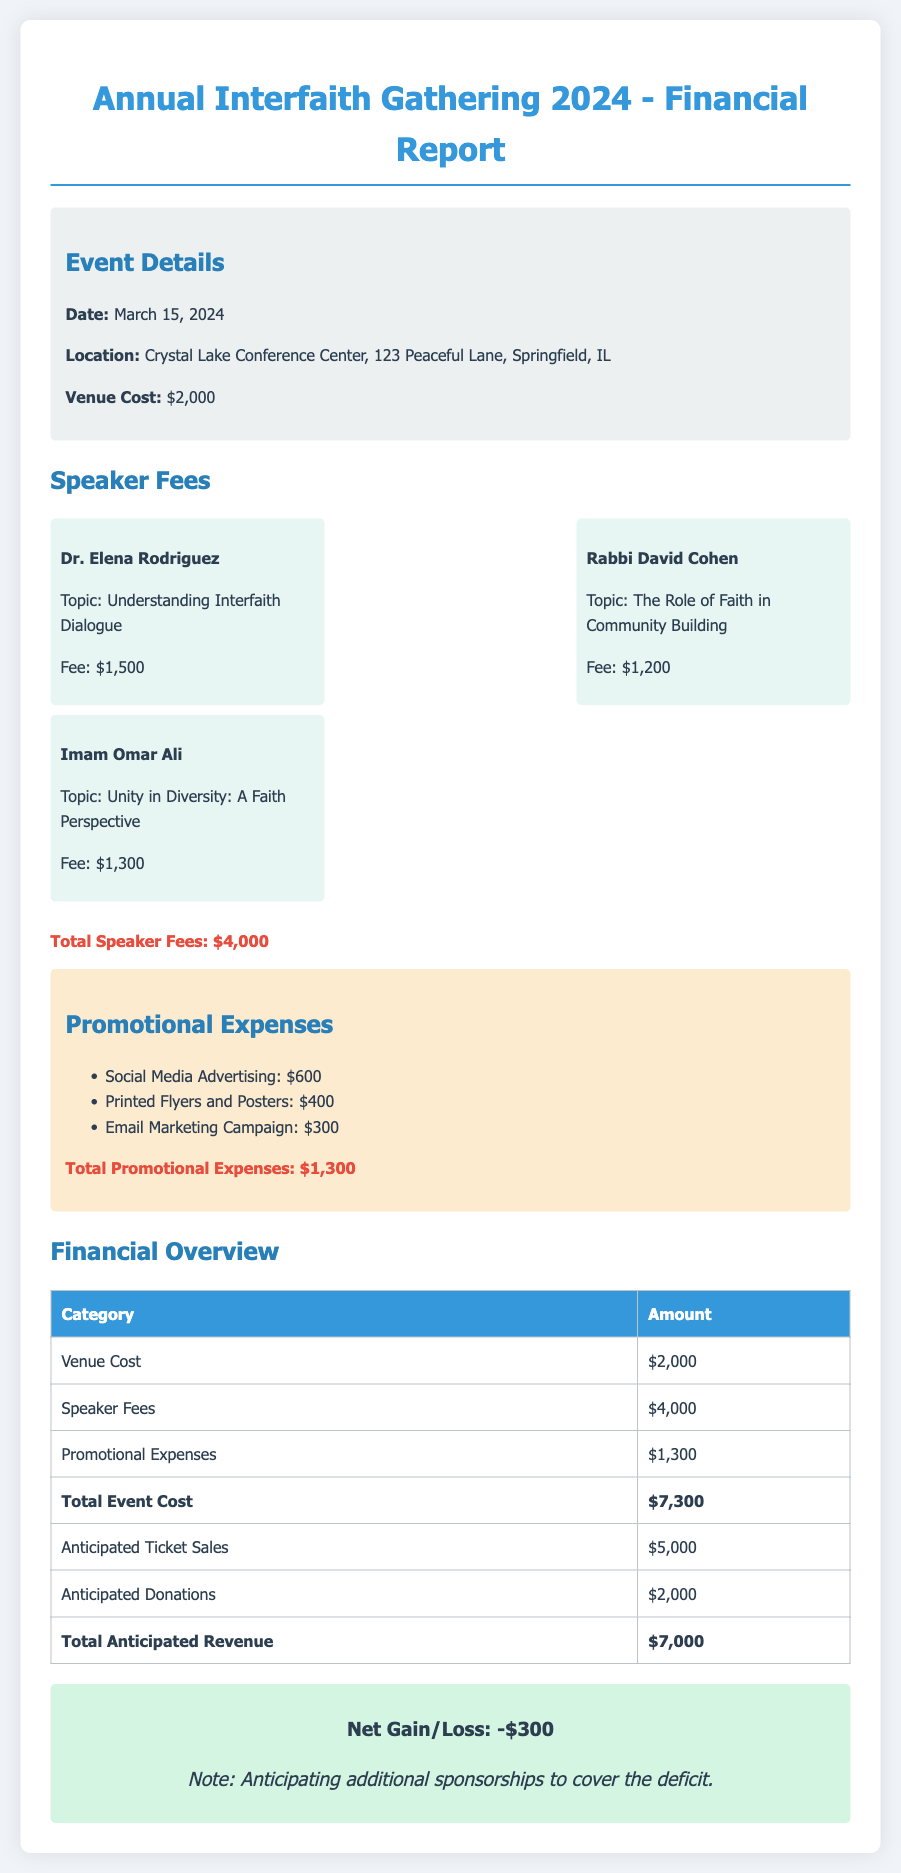What is the date of the event? The date of the event is specified in the document as March 15, 2024.
Answer: March 15, 2024 What is the venue cost? The venue cost is clearly listed in the document as $2,000.
Answer: $2,000 Who is the speaker discussing "Unity in Diversity: A Faith Perspective"? The speaker's name and their topic are provided; Imam Omar Ali is discussing "Unity in Diversity: A Faith Perspective."
Answer: Imam Omar Ali What is the total amount of anticipated donations? The anticipated donations are mentioned in the financial overview section as $2,000.
Answer: $2,000 What is the total event cost? The document consolidates expenses to provide the total event cost, which is $7,300.
Answer: $7,300 How much is budgeted for social media advertising? The budget for social media advertising is specified as $600 in the promotional expenses section.
Answer: $600 What is the net gain/loss for the event? The net gain/loss is indicated in the financial overview; it mentions a loss of $300.
Answer: -$300 Which speaker charges the highest fee? The document states that Dr. Elena Rodriguez has the highest fee of $1,500.
Answer: Dr. Elena Rodriguez What is the total for promotional expenses? The total promotional expenses calculated and displayed in the report are $1,300.
Answer: $1,300 